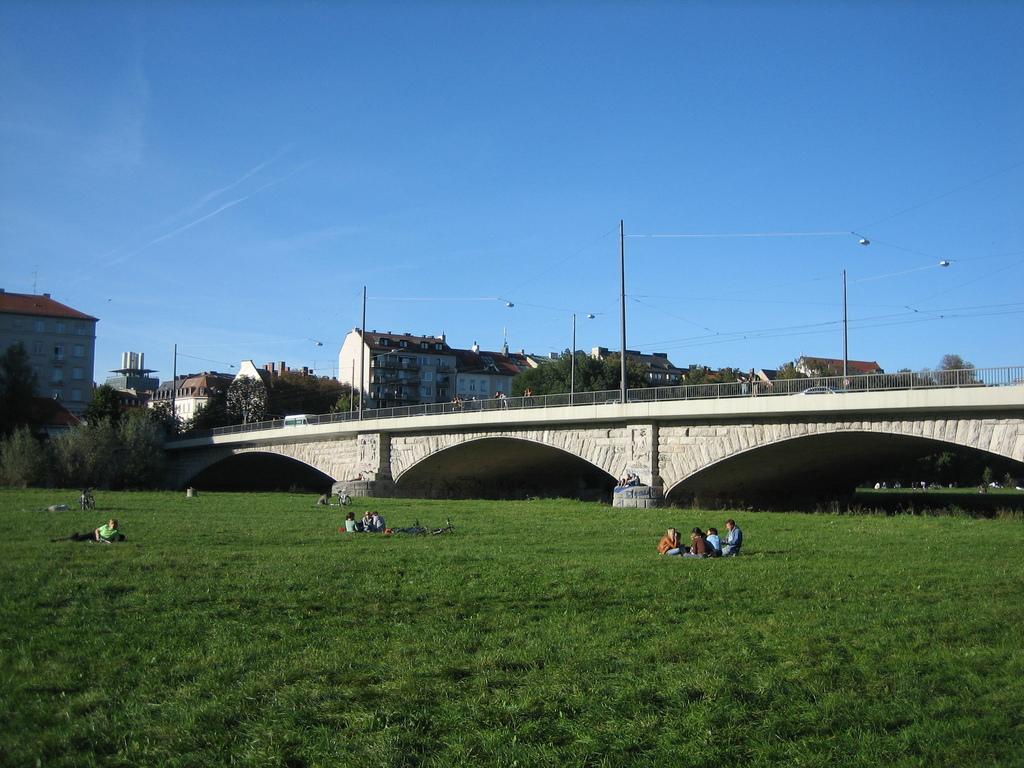In one or two sentences, can you explain what this image depicts? In this image we can see a few people sitting in the grass, there we can see a few people on the bridge, fence, few trees, few electrical poles, cables and lights. 